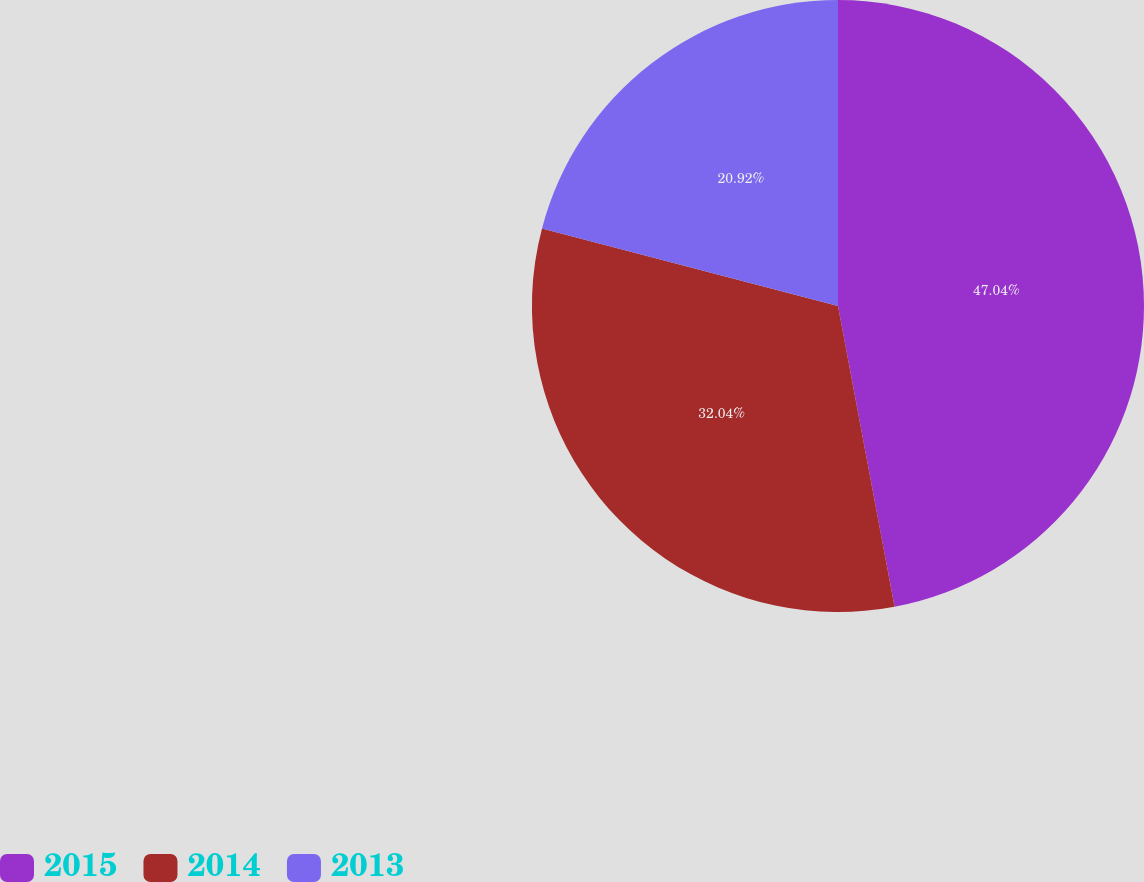Convert chart to OTSL. <chart><loc_0><loc_0><loc_500><loc_500><pie_chart><fcel>2015<fcel>2014<fcel>2013<nl><fcel>47.04%<fcel>32.04%<fcel>20.92%<nl></chart> 